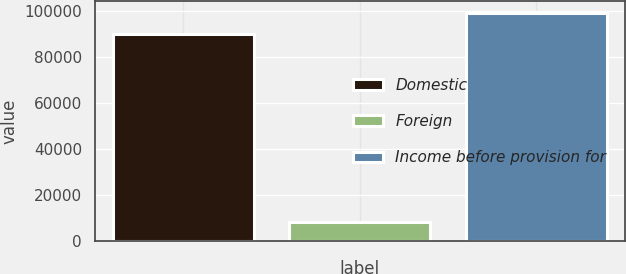Convert chart. <chart><loc_0><loc_0><loc_500><loc_500><bar_chart><fcel>Domestic<fcel>Foreign<fcel>Income before provision for<nl><fcel>90009<fcel>8460<fcel>99009.9<nl></chart> 